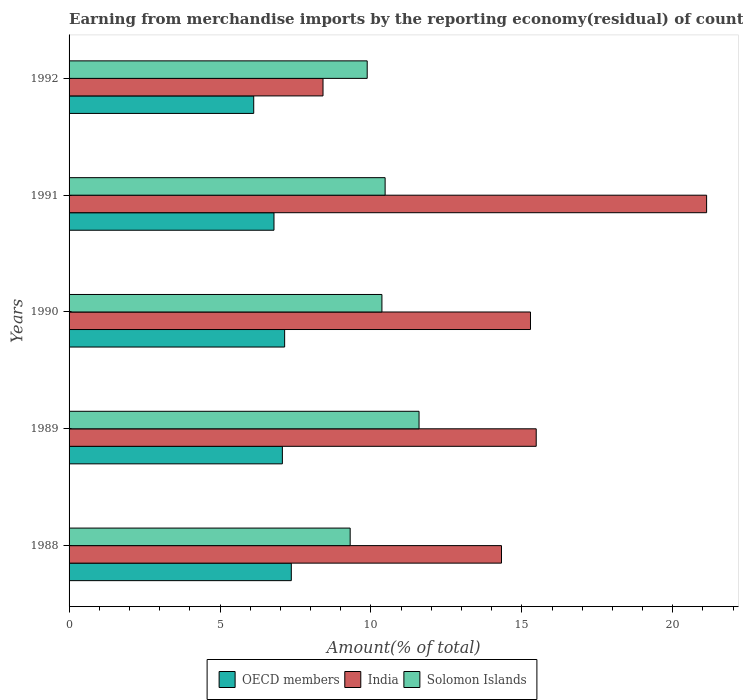How many groups of bars are there?
Offer a terse response. 5. Are the number of bars per tick equal to the number of legend labels?
Offer a terse response. Yes. In how many cases, is the number of bars for a given year not equal to the number of legend labels?
Your response must be concise. 0. What is the percentage of amount earned from merchandise imports in India in 1989?
Give a very brief answer. 15.48. Across all years, what is the maximum percentage of amount earned from merchandise imports in Solomon Islands?
Offer a very short reply. 11.59. Across all years, what is the minimum percentage of amount earned from merchandise imports in OECD members?
Keep it short and to the point. 6.12. In which year was the percentage of amount earned from merchandise imports in Solomon Islands minimum?
Provide a succinct answer. 1988. What is the total percentage of amount earned from merchandise imports in India in the graph?
Your answer should be very brief. 74.62. What is the difference between the percentage of amount earned from merchandise imports in India in 1989 and that in 1992?
Provide a succinct answer. 7.06. What is the difference between the percentage of amount earned from merchandise imports in OECD members in 1990 and the percentage of amount earned from merchandise imports in Solomon Islands in 1989?
Your response must be concise. -4.45. What is the average percentage of amount earned from merchandise imports in OECD members per year?
Offer a terse response. 6.9. In the year 1990, what is the difference between the percentage of amount earned from merchandise imports in OECD members and percentage of amount earned from merchandise imports in Solomon Islands?
Your answer should be very brief. -3.22. In how many years, is the percentage of amount earned from merchandise imports in Solomon Islands greater than 7 %?
Provide a short and direct response. 5. What is the ratio of the percentage of amount earned from merchandise imports in India in 1988 to that in 1990?
Ensure brevity in your answer.  0.94. Is the percentage of amount earned from merchandise imports in India in 1988 less than that in 1989?
Your answer should be very brief. Yes. What is the difference between the highest and the second highest percentage of amount earned from merchandise imports in Solomon Islands?
Ensure brevity in your answer.  1.12. What is the difference between the highest and the lowest percentage of amount earned from merchandise imports in Solomon Islands?
Ensure brevity in your answer.  2.28. Is the sum of the percentage of amount earned from merchandise imports in OECD members in 1989 and 1991 greater than the maximum percentage of amount earned from merchandise imports in Solomon Islands across all years?
Make the answer very short. Yes. What does the 3rd bar from the top in 1992 represents?
Give a very brief answer. OECD members. What does the 3rd bar from the bottom in 1988 represents?
Offer a terse response. Solomon Islands. How many bars are there?
Your answer should be compact. 15. Are the values on the major ticks of X-axis written in scientific E-notation?
Ensure brevity in your answer.  No. Does the graph contain any zero values?
Your answer should be very brief. No. Does the graph contain grids?
Provide a succinct answer. No. How many legend labels are there?
Offer a very short reply. 3. How are the legend labels stacked?
Your response must be concise. Horizontal. What is the title of the graph?
Offer a terse response. Earning from merchandise imports by the reporting economy(residual) of countries. What is the label or title of the X-axis?
Keep it short and to the point. Amount(% of total). What is the Amount(% of total) of OECD members in 1988?
Offer a terse response. 7.36. What is the Amount(% of total) of India in 1988?
Offer a very short reply. 14.33. What is the Amount(% of total) of Solomon Islands in 1988?
Your answer should be very brief. 9.31. What is the Amount(% of total) in OECD members in 1989?
Your answer should be very brief. 7.07. What is the Amount(% of total) of India in 1989?
Keep it short and to the point. 15.48. What is the Amount(% of total) of Solomon Islands in 1989?
Ensure brevity in your answer.  11.59. What is the Amount(% of total) of OECD members in 1990?
Your answer should be very brief. 7.14. What is the Amount(% of total) in India in 1990?
Give a very brief answer. 15.29. What is the Amount(% of total) in Solomon Islands in 1990?
Your answer should be very brief. 10.36. What is the Amount(% of total) of OECD members in 1991?
Provide a short and direct response. 6.79. What is the Amount(% of total) in India in 1991?
Provide a short and direct response. 21.12. What is the Amount(% of total) in Solomon Islands in 1991?
Your answer should be compact. 10.47. What is the Amount(% of total) in OECD members in 1992?
Keep it short and to the point. 6.12. What is the Amount(% of total) in India in 1992?
Your answer should be compact. 8.41. What is the Amount(% of total) in Solomon Islands in 1992?
Make the answer very short. 9.88. Across all years, what is the maximum Amount(% of total) of OECD members?
Offer a very short reply. 7.36. Across all years, what is the maximum Amount(% of total) of India?
Provide a short and direct response. 21.12. Across all years, what is the maximum Amount(% of total) in Solomon Islands?
Offer a very short reply. 11.59. Across all years, what is the minimum Amount(% of total) of OECD members?
Give a very brief answer. 6.12. Across all years, what is the minimum Amount(% of total) in India?
Your answer should be compact. 8.41. Across all years, what is the minimum Amount(% of total) of Solomon Islands?
Give a very brief answer. 9.31. What is the total Amount(% of total) in OECD members in the graph?
Make the answer very short. 34.48. What is the total Amount(% of total) of India in the graph?
Your answer should be compact. 74.62. What is the total Amount(% of total) of Solomon Islands in the graph?
Your answer should be very brief. 51.62. What is the difference between the Amount(% of total) in OECD members in 1988 and that in 1989?
Your response must be concise. 0.3. What is the difference between the Amount(% of total) of India in 1988 and that in 1989?
Your answer should be very brief. -1.15. What is the difference between the Amount(% of total) of Solomon Islands in 1988 and that in 1989?
Keep it short and to the point. -2.28. What is the difference between the Amount(% of total) in OECD members in 1988 and that in 1990?
Offer a terse response. 0.22. What is the difference between the Amount(% of total) of India in 1988 and that in 1990?
Make the answer very short. -0.96. What is the difference between the Amount(% of total) of Solomon Islands in 1988 and that in 1990?
Provide a succinct answer. -1.05. What is the difference between the Amount(% of total) of OECD members in 1988 and that in 1991?
Keep it short and to the point. 0.57. What is the difference between the Amount(% of total) of India in 1988 and that in 1991?
Your answer should be compact. -6.8. What is the difference between the Amount(% of total) in Solomon Islands in 1988 and that in 1991?
Offer a very short reply. -1.16. What is the difference between the Amount(% of total) in OECD members in 1988 and that in 1992?
Offer a very short reply. 1.25. What is the difference between the Amount(% of total) of India in 1988 and that in 1992?
Your response must be concise. 5.91. What is the difference between the Amount(% of total) of Solomon Islands in 1988 and that in 1992?
Ensure brevity in your answer.  -0.56. What is the difference between the Amount(% of total) in OECD members in 1989 and that in 1990?
Make the answer very short. -0.08. What is the difference between the Amount(% of total) in India in 1989 and that in 1990?
Your answer should be compact. 0.19. What is the difference between the Amount(% of total) in Solomon Islands in 1989 and that in 1990?
Ensure brevity in your answer.  1.23. What is the difference between the Amount(% of total) of OECD members in 1989 and that in 1991?
Keep it short and to the point. 0.28. What is the difference between the Amount(% of total) of India in 1989 and that in 1991?
Ensure brevity in your answer.  -5.65. What is the difference between the Amount(% of total) in Solomon Islands in 1989 and that in 1991?
Keep it short and to the point. 1.12. What is the difference between the Amount(% of total) of OECD members in 1989 and that in 1992?
Keep it short and to the point. 0.95. What is the difference between the Amount(% of total) of India in 1989 and that in 1992?
Keep it short and to the point. 7.06. What is the difference between the Amount(% of total) in Solomon Islands in 1989 and that in 1992?
Give a very brief answer. 1.72. What is the difference between the Amount(% of total) of OECD members in 1990 and that in 1991?
Provide a succinct answer. 0.35. What is the difference between the Amount(% of total) of India in 1990 and that in 1991?
Your answer should be compact. -5.84. What is the difference between the Amount(% of total) in Solomon Islands in 1990 and that in 1991?
Give a very brief answer. -0.11. What is the difference between the Amount(% of total) in OECD members in 1990 and that in 1992?
Your answer should be compact. 1.02. What is the difference between the Amount(% of total) of India in 1990 and that in 1992?
Provide a succinct answer. 6.87. What is the difference between the Amount(% of total) of Solomon Islands in 1990 and that in 1992?
Keep it short and to the point. 0.49. What is the difference between the Amount(% of total) in OECD members in 1991 and that in 1992?
Your answer should be compact. 0.67. What is the difference between the Amount(% of total) in India in 1991 and that in 1992?
Keep it short and to the point. 12.71. What is the difference between the Amount(% of total) of Solomon Islands in 1991 and that in 1992?
Give a very brief answer. 0.59. What is the difference between the Amount(% of total) in OECD members in 1988 and the Amount(% of total) in India in 1989?
Offer a very short reply. -8.11. What is the difference between the Amount(% of total) in OECD members in 1988 and the Amount(% of total) in Solomon Islands in 1989?
Your answer should be compact. -4.23. What is the difference between the Amount(% of total) of India in 1988 and the Amount(% of total) of Solomon Islands in 1989?
Your answer should be compact. 2.73. What is the difference between the Amount(% of total) in OECD members in 1988 and the Amount(% of total) in India in 1990?
Offer a very short reply. -7.92. What is the difference between the Amount(% of total) of OECD members in 1988 and the Amount(% of total) of Solomon Islands in 1990?
Keep it short and to the point. -3. What is the difference between the Amount(% of total) in India in 1988 and the Amount(% of total) in Solomon Islands in 1990?
Your answer should be very brief. 3.96. What is the difference between the Amount(% of total) in OECD members in 1988 and the Amount(% of total) in India in 1991?
Ensure brevity in your answer.  -13.76. What is the difference between the Amount(% of total) in OECD members in 1988 and the Amount(% of total) in Solomon Islands in 1991?
Provide a short and direct response. -3.11. What is the difference between the Amount(% of total) in India in 1988 and the Amount(% of total) in Solomon Islands in 1991?
Offer a very short reply. 3.86. What is the difference between the Amount(% of total) of OECD members in 1988 and the Amount(% of total) of India in 1992?
Your answer should be compact. -1.05. What is the difference between the Amount(% of total) of OECD members in 1988 and the Amount(% of total) of Solomon Islands in 1992?
Ensure brevity in your answer.  -2.51. What is the difference between the Amount(% of total) of India in 1988 and the Amount(% of total) of Solomon Islands in 1992?
Offer a terse response. 4.45. What is the difference between the Amount(% of total) of OECD members in 1989 and the Amount(% of total) of India in 1990?
Offer a very short reply. -8.22. What is the difference between the Amount(% of total) of OECD members in 1989 and the Amount(% of total) of Solomon Islands in 1990?
Your response must be concise. -3.3. What is the difference between the Amount(% of total) in India in 1989 and the Amount(% of total) in Solomon Islands in 1990?
Make the answer very short. 5.11. What is the difference between the Amount(% of total) of OECD members in 1989 and the Amount(% of total) of India in 1991?
Ensure brevity in your answer.  -14.06. What is the difference between the Amount(% of total) of OECD members in 1989 and the Amount(% of total) of Solomon Islands in 1991?
Your response must be concise. -3.4. What is the difference between the Amount(% of total) of India in 1989 and the Amount(% of total) of Solomon Islands in 1991?
Your response must be concise. 5.01. What is the difference between the Amount(% of total) in OECD members in 1989 and the Amount(% of total) in India in 1992?
Give a very brief answer. -1.35. What is the difference between the Amount(% of total) of OECD members in 1989 and the Amount(% of total) of Solomon Islands in 1992?
Your answer should be compact. -2.81. What is the difference between the Amount(% of total) of India in 1989 and the Amount(% of total) of Solomon Islands in 1992?
Make the answer very short. 5.6. What is the difference between the Amount(% of total) in OECD members in 1990 and the Amount(% of total) in India in 1991?
Ensure brevity in your answer.  -13.98. What is the difference between the Amount(% of total) of OECD members in 1990 and the Amount(% of total) of Solomon Islands in 1991?
Make the answer very short. -3.33. What is the difference between the Amount(% of total) in India in 1990 and the Amount(% of total) in Solomon Islands in 1991?
Provide a succinct answer. 4.82. What is the difference between the Amount(% of total) of OECD members in 1990 and the Amount(% of total) of India in 1992?
Give a very brief answer. -1.27. What is the difference between the Amount(% of total) of OECD members in 1990 and the Amount(% of total) of Solomon Islands in 1992?
Your answer should be very brief. -2.74. What is the difference between the Amount(% of total) of India in 1990 and the Amount(% of total) of Solomon Islands in 1992?
Provide a succinct answer. 5.41. What is the difference between the Amount(% of total) of OECD members in 1991 and the Amount(% of total) of India in 1992?
Make the answer very short. -1.62. What is the difference between the Amount(% of total) of OECD members in 1991 and the Amount(% of total) of Solomon Islands in 1992?
Keep it short and to the point. -3.09. What is the difference between the Amount(% of total) in India in 1991 and the Amount(% of total) in Solomon Islands in 1992?
Provide a succinct answer. 11.24. What is the average Amount(% of total) in OECD members per year?
Keep it short and to the point. 6.9. What is the average Amount(% of total) in India per year?
Provide a short and direct response. 14.92. What is the average Amount(% of total) in Solomon Islands per year?
Your answer should be very brief. 10.32. In the year 1988, what is the difference between the Amount(% of total) of OECD members and Amount(% of total) of India?
Make the answer very short. -6.96. In the year 1988, what is the difference between the Amount(% of total) in OECD members and Amount(% of total) in Solomon Islands?
Give a very brief answer. -1.95. In the year 1988, what is the difference between the Amount(% of total) in India and Amount(% of total) in Solomon Islands?
Offer a terse response. 5.01. In the year 1989, what is the difference between the Amount(% of total) of OECD members and Amount(% of total) of India?
Keep it short and to the point. -8.41. In the year 1989, what is the difference between the Amount(% of total) in OECD members and Amount(% of total) in Solomon Islands?
Ensure brevity in your answer.  -4.53. In the year 1989, what is the difference between the Amount(% of total) of India and Amount(% of total) of Solomon Islands?
Your answer should be compact. 3.88. In the year 1990, what is the difference between the Amount(% of total) of OECD members and Amount(% of total) of India?
Provide a short and direct response. -8.14. In the year 1990, what is the difference between the Amount(% of total) of OECD members and Amount(% of total) of Solomon Islands?
Provide a succinct answer. -3.22. In the year 1990, what is the difference between the Amount(% of total) of India and Amount(% of total) of Solomon Islands?
Offer a terse response. 4.92. In the year 1991, what is the difference between the Amount(% of total) in OECD members and Amount(% of total) in India?
Ensure brevity in your answer.  -14.33. In the year 1991, what is the difference between the Amount(% of total) in OECD members and Amount(% of total) in Solomon Islands?
Provide a succinct answer. -3.68. In the year 1991, what is the difference between the Amount(% of total) in India and Amount(% of total) in Solomon Islands?
Keep it short and to the point. 10.65. In the year 1992, what is the difference between the Amount(% of total) in OECD members and Amount(% of total) in India?
Offer a terse response. -2.3. In the year 1992, what is the difference between the Amount(% of total) in OECD members and Amount(% of total) in Solomon Islands?
Offer a very short reply. -3.76. In the year 1992, what is the difference between the Amount(% of total) of India and Amount(% of total) of Solomon Islands?
Provide a short and direct response. -1.46. What is the ratio of the Amount(% of total) in OECD members in 1988 to that in 1989?
Offer a terse response. 1.04. What is the ratio of the Amount(% of total) in India in 1988 to that in 1989?
Provide a short and direct response. 0.93. What is the ratio of the Amount(% of total) in Solomon Islands in 1988 to that in 1989?
Give a very brief answer. 0.8. What is the ratio of the Amount(% of total) in OECD members in 1988 to that in 1990?
Provide a short and direct response. 1.03. What is the ratio of the Amount(% of total) in India in 1988 to that in 1990?
Give a very brief answer. 0.94. What is the ratio of the Amount(% of total) of Solomon Islands in 1988 to that in 1990?
Your answer should be compact. 0.9. What is the ratio of the Amount(% of total) of OECD members in 1988 to that in 1991?
Provide a succinct answer. 1.08. What is the ratio of the Amount(% of total) of India in 1988 to that in 1991?
Make the answer very short. 0.68. What is the ratio of the Amount(% of total) of Solomon Islands in 1988 to that in 1991?
Provide a succinct answer. 0.89. What is the ratio of the Amount(% of total) of OECD members in 1988 to that in 1992?
Keep it short and to the point. 1.2. What is the ratio of the Amount(% of total) in India in 1988 to that in 1992?
Provide a succinct answer. 1.7. What is the ratio of the Amount(% of total) of Solomon Islands in 1988 to that in 1992?
Offer a very short reply. 0.94. What is the ratio of the Amount(% of total) of OECD members in 1989 to that in 1990?
Provide a short and direct response. 0.99. What is the ratio of the Amount(% of total) in India in 1989 to that in 1990?
Provide a short and direct response. 1.01. What is the ratio of the Amount(% of total) in Solomon Islands in 1989 to that in 1990?
Ensure brevity in your answer.  1.12. What is the ratio of the Amount(% of total) of OECD members in 1989 to that in 1991?
Your answer should be very brief. 1.04. What is the ratio of the Amount(% of total) of India in 1989 to that in 1991?
Offer a terse response. 0.73. What is the ratio of the Amount(% of total) of Solomon Islands in 1989 to that in 1991?
Keep it short and to the point. 1.11. What is the ratio of the Amount(% of total) in OECD members in 1989 to that in 1992?
Make the answer very short. 1.16. What is the ratio of the Amount(% of total) in India in 1989 to that in 1992?
Offer a terse response. 1.84. What is the ratio of the Amount(% of total) in Solomon Islands in 1989 to that in 1992?
Your response must be concise. 1.17. What is the ratio of the Amount(% of total) of OECD members in 1990 to that in 1991?
Ensure brevity in your answer.  1.05. What is the ratio of the Amount(% of total) in India in 1990 to that in 1991?
Keep it short and to the point. 0.72. What is the ratio of the Amount(% of total) of OECD members in 1990 to that in 1992?
Offer a very short reply. 1.17. What is the ratio of the Amount(% of total) of India in 1990 to that in 1992?
Ensure brevity in your answer.  1.82. What is the ratio of the Amount(% of total) of Solomon Islands in 1990 to that in 1992?
Your answer should be very brief. 1.05. What is the ratio of the Amount(% of total) of OECD members in 1991 to that in 1992?
Your answer should be very brief. 1.11. What is the ratio of the Amount(% of total) of India in 1991 to that in 1992?
Your response must be concise. 2.51. What is the ratio of the Amount(% of total) of Solomon Islands in 1991 to that in 1992?
Your answer should be compact. 1.06. What is the difference between the highest and the second highest Amount(% of total) in OECD members?
Offer a very short reply. 0.22. What is the difference between the highest and the second highest Amount(% of total) of India?
Make the answer very short. 5.65. What is the difference between the highest and the second highest Amount(% of total) of Solomon Islands?
Make the answer very short. 1.12. What is the difference between the highest and the lowest Amount(% of total) of OECD members?
Offer a very short reply. 1.25. What is the difference between the highest and the lowest Amount(% of total) in India?
Make the answer very short. 12.71. What is the difference between the highest and the lowest Amount(% of total) of Solomon Islands?
Make the answer very short. 2.28. 